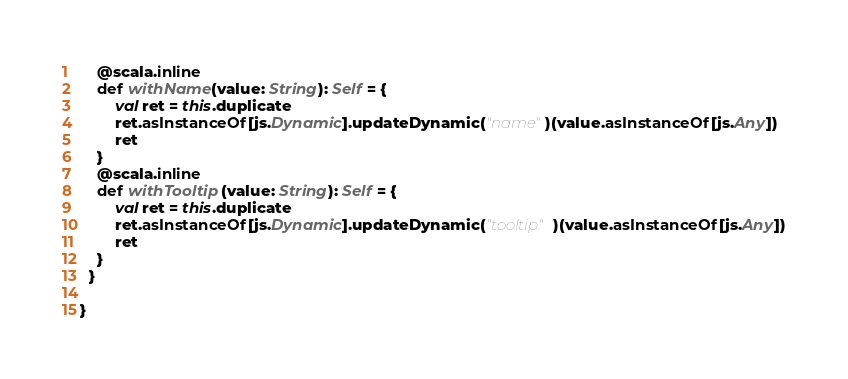Convert code to text. <code><loc_0><loc_0><loc_500><loc_500><_Scala_>    @scala.inline
    def withName(value: String): Self = {
        val ret = this.duplicate
        ret.asInstanceOf[js.Dynamic].updateDynamic("name")(value.asInstanceOf[js.Any])
        ret
    }
    @scala.inline
    def withTooltip(value: String): Self = {
        val ret = this.duplicate
        ret.asInstanceOf[js.Dynamic].updateDynamic("tooltip")(value.asInstanceOf[js.Any])
        ret
    }
  }
  
}

</code> 